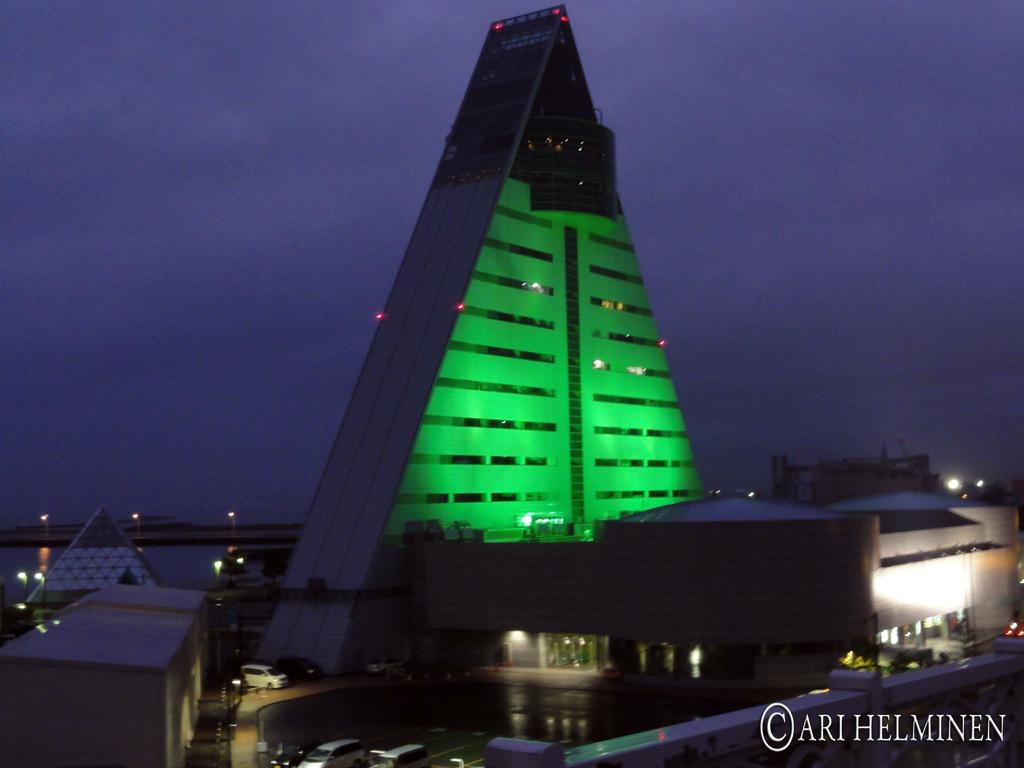What type of structures can be seen in the image? There are buildings in the image. What else is visible in the image besides the buildings? There are lights visible in the image, as well as a vehicle. What can be seen in the sky in the image? The sky is visible in the image. Is there any text present in the image? Yes, there is text on the image. Can you describe the growth of the rabbit in the image? There is no rabbit present in the image, so it is not possible to describe its growth. 